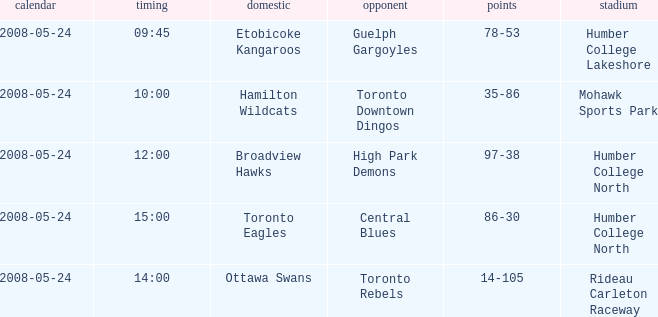Who was the away team of the game at the time 15:00? Central Blues. 